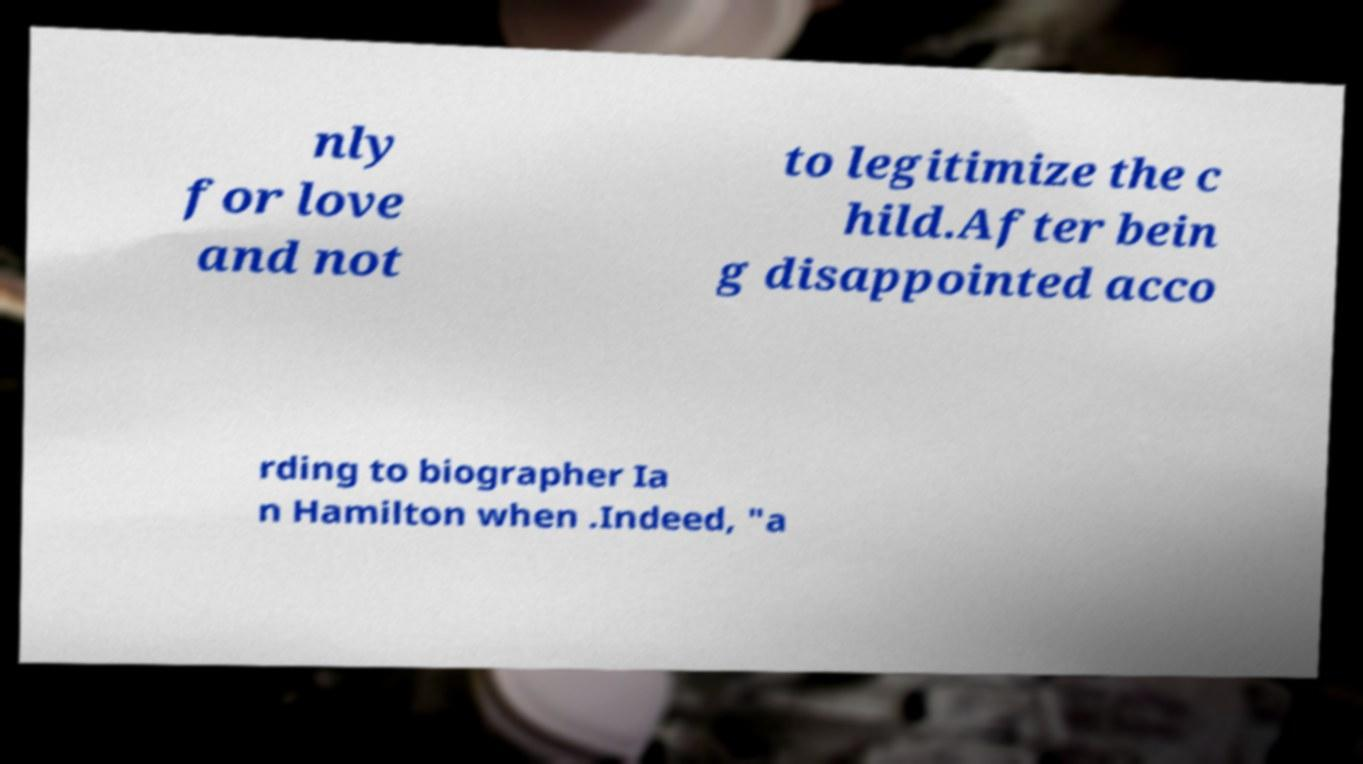Can you accurately transcribe the text from the provided image for me? nly for love and not to legitimize the c hild.After bein g disappointed acco rding to biographer Ia n Hamilton when .Indeed, "a 